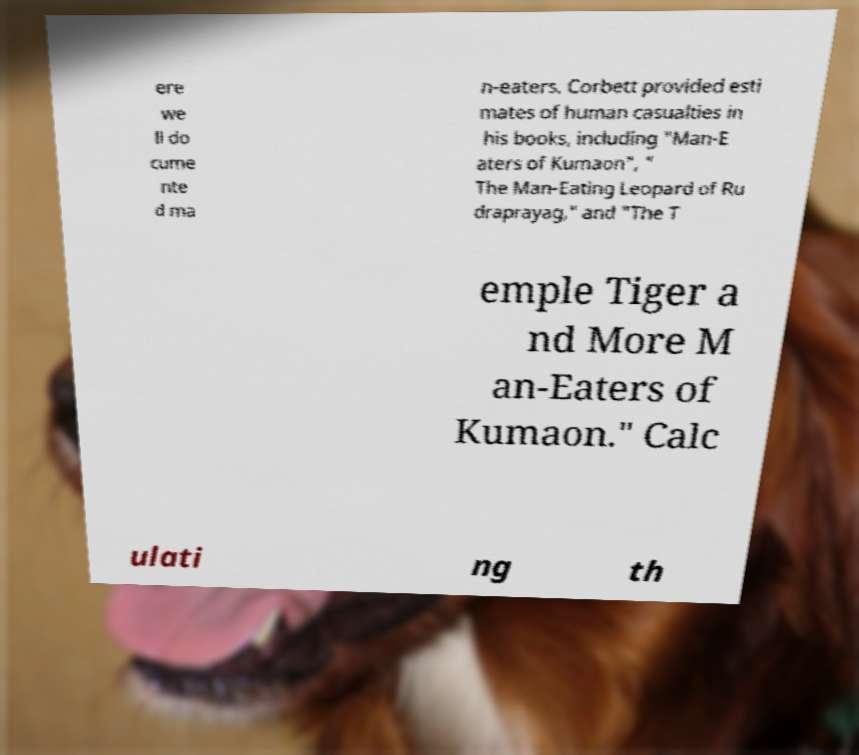There's text embedded in this image that I need extracted. Can you transcribe it verbatim? ere we ll do cume nte d ma n-eaters. Corbett provided esti mates of human casualties in his books, including "Man-E aters of Kumaon", " The Man-Eating Leopard of Ru draprayag," and "The T emple Tiger a nd More M an-Eaters of Kumaon." Calc ulati ng th 